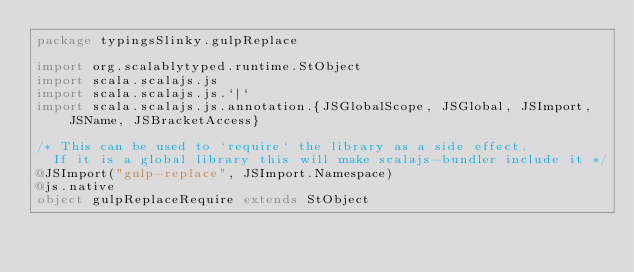Convert code to text. <code><loc_0><loc_0><loc_500><loc_500><_Scala_>package typingsSlinky.gulpReplace

import org.scalablytyped.runtime.StObject
import scala.scalajs.js
import scala.scalajs.js.`|`
import scala.scalajs.js.annotation.{JSGlobalScope, JSGlobal, JSImport, JSName, JSBracketAccess}

/* This can be used to `require` the library as a side effect.
  If it is a global library this will make scalajs-bundler include it */
@JSImport("gulp-replace", JSImport.Namespace)
@js.native
object gulpReplaceRequire extends StObject
</code> 